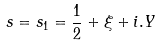<formula> <loc_0><loc_0><loc_500><loc_500>s = s _ { 1 } = \frac { 1 } { 2 } + \xi + i . Y</formula> 